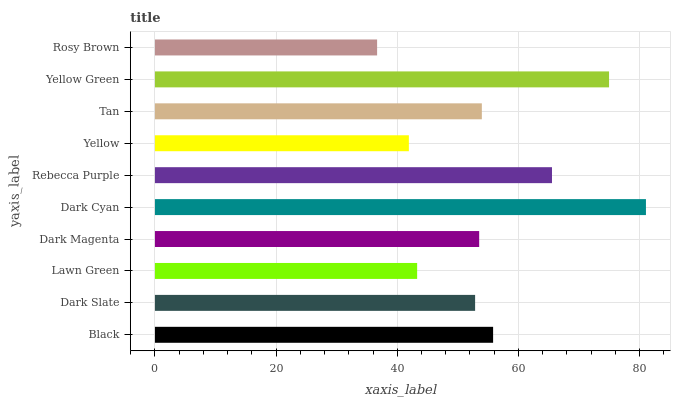Is Rosy Brown the minimum?
Answer yes or no. Yes. Is Dark Cyan the maximum?
Answer yes or no. Yes. Is Dark Slate the minimum?
Answer yes or no. No. Is Dark Slate the maximum?
Answer yes or no. No. Is Black greater than Dark Slate?
Answer yes or no. Yes. Is Dark Slate less than Black?
Answer yes or no. Yes. Is Dark Slate greater than Black?
Answer yes or no. No. Is Black less than Dark Slate?
Answer yes or no. No. Is Tan the high median?
Answer yes or no. Yes. Is Dark Magenta the low median?
Answer yes or no. Yes. Is Black the high median?
Answer yes or no. No. Is Yellow the low median?
Answer yes or no. No. 